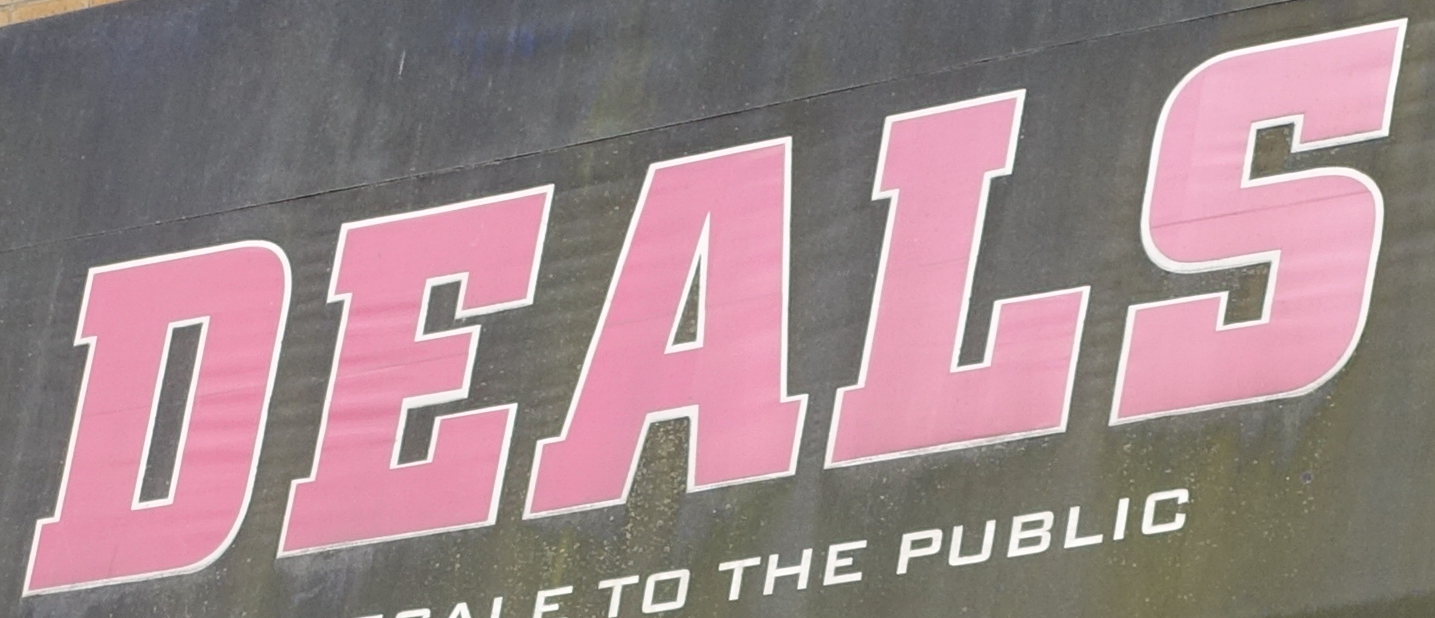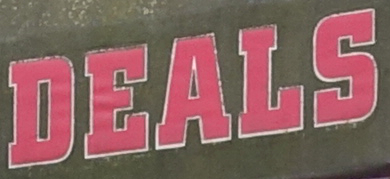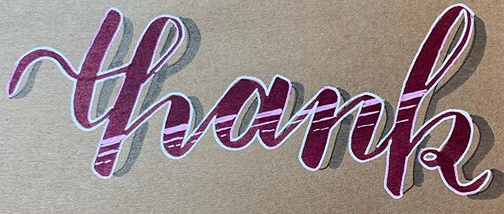Read the text from these images in sequence, separated by a semicolon. DEALS; DEALS; thank 